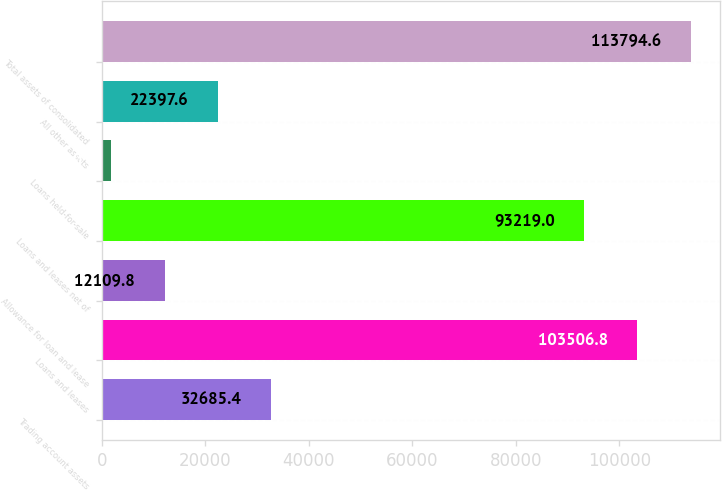<chart> <loc_0><loc_0><loc_500><loc_500><bar_chart><fcel>Trading account assets<fcel>Loans and leases<fcel>Allowance for loan and lease<fcel>Loans and leases net of<fcel>Loans held-for-sale<fcel>All other assets<fcel>Total assets of consolidated<nl><fcel>32685.4<fcel>103507<fcel>12109.8<fcel>93219<fcel>1822<fcel>22397.6<fcel>113795<nl></chart> 